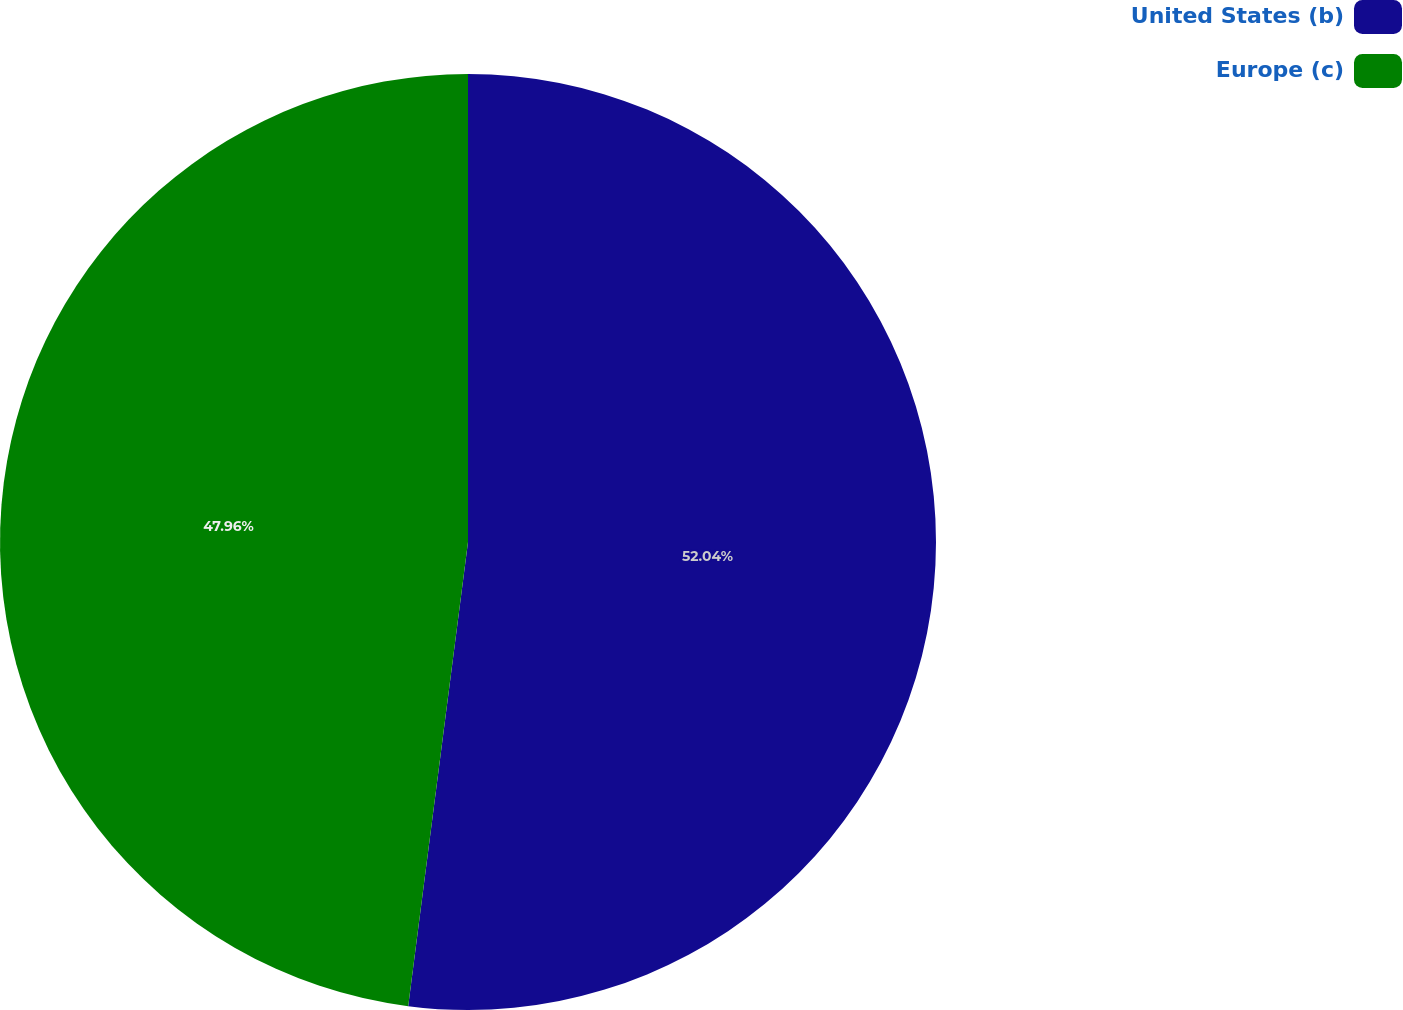Convert chart. <chart><loc_0><loc_0><loc_500><loc_500><pie_chart><fcel>United States (b)<fcel>Europe (c)<nl><fcel>52.04%<fcel>47.96%<nl></chart> 